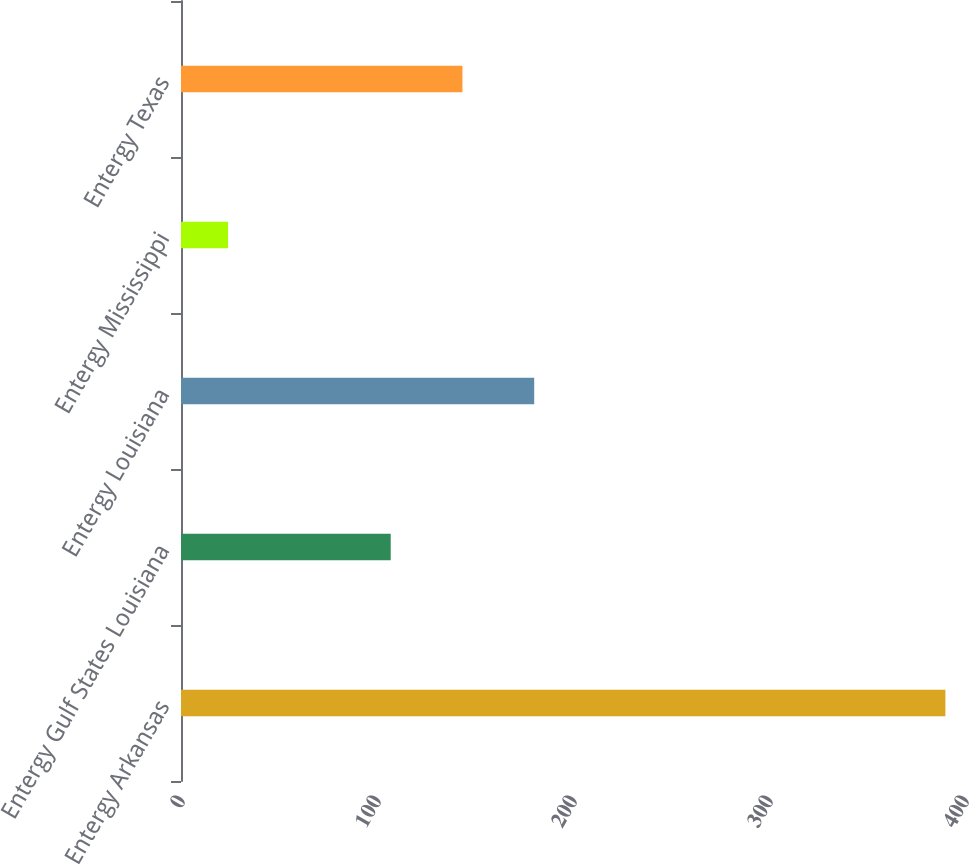Convert chart. <chart><loc_0><loc_0><loc_500><loc_500><bar_chart><fcel>Entergy Arkansas<fcel>Entergy Gulf States Louisiana<fcel>Entergy Louisiana<fcel>Entergy Mississippi<fcel>Entergy Texas<nl><fcel>390<fcel>107<fcel>180.2<fcel>24<fcel>143.6<nl></chart> 